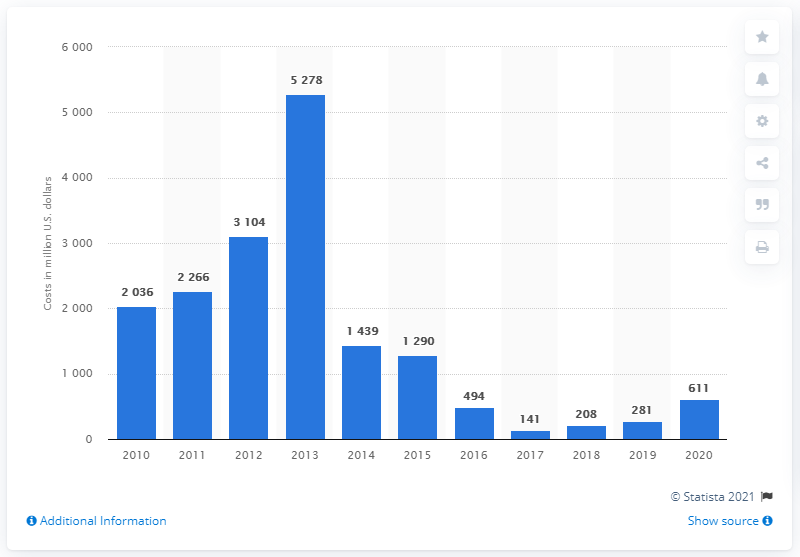Indicate a few pertinent items in this graphic. In 2020, Royal Dutch Shell committed a significant amount of resources to exploration operations. Specifically, the company spent 611 on these efforts. 